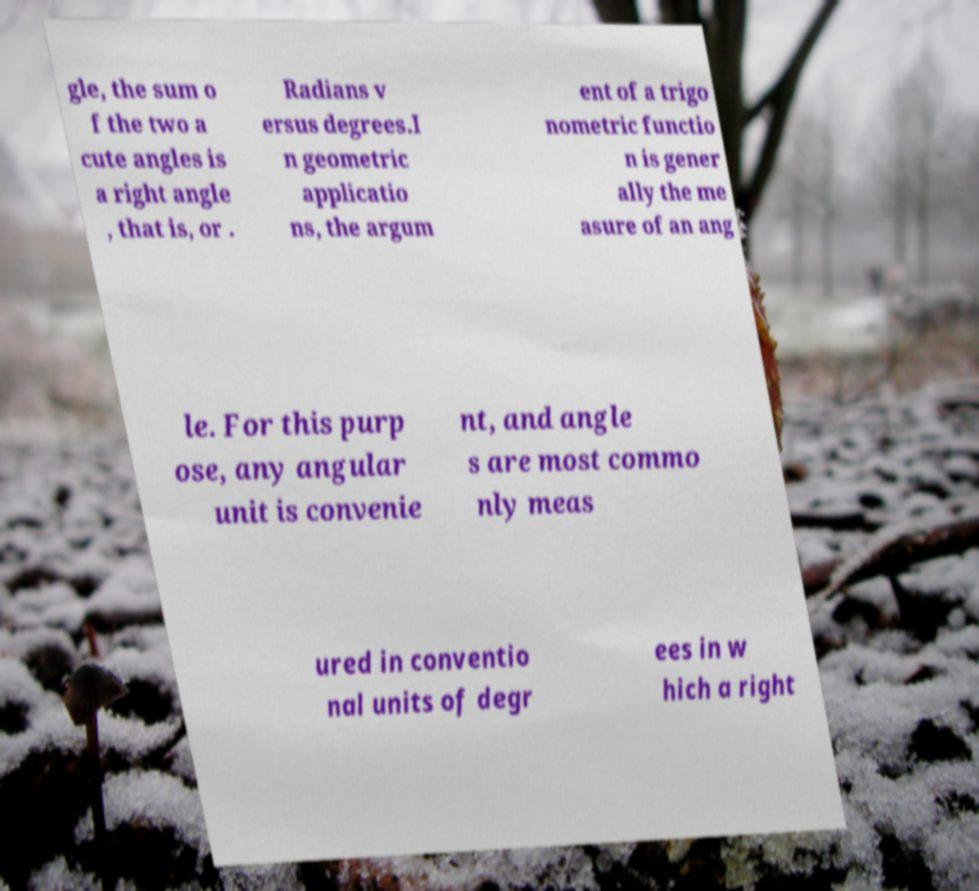What messages or text are displayed in this image? I need them in a readable, typed format. gle, the sum o f the two a cute angles is a right angle , that is, or . Radians v ersus degrees.I n geometric applicatio ns, the argum ent of a trigo nometric functio n is gener ally the me asure of an ang le. For this purp ose, any angular unit is convenie nt, and angle s are most commo nly meas ured in conventio nal units of degr ees in w hich a right 